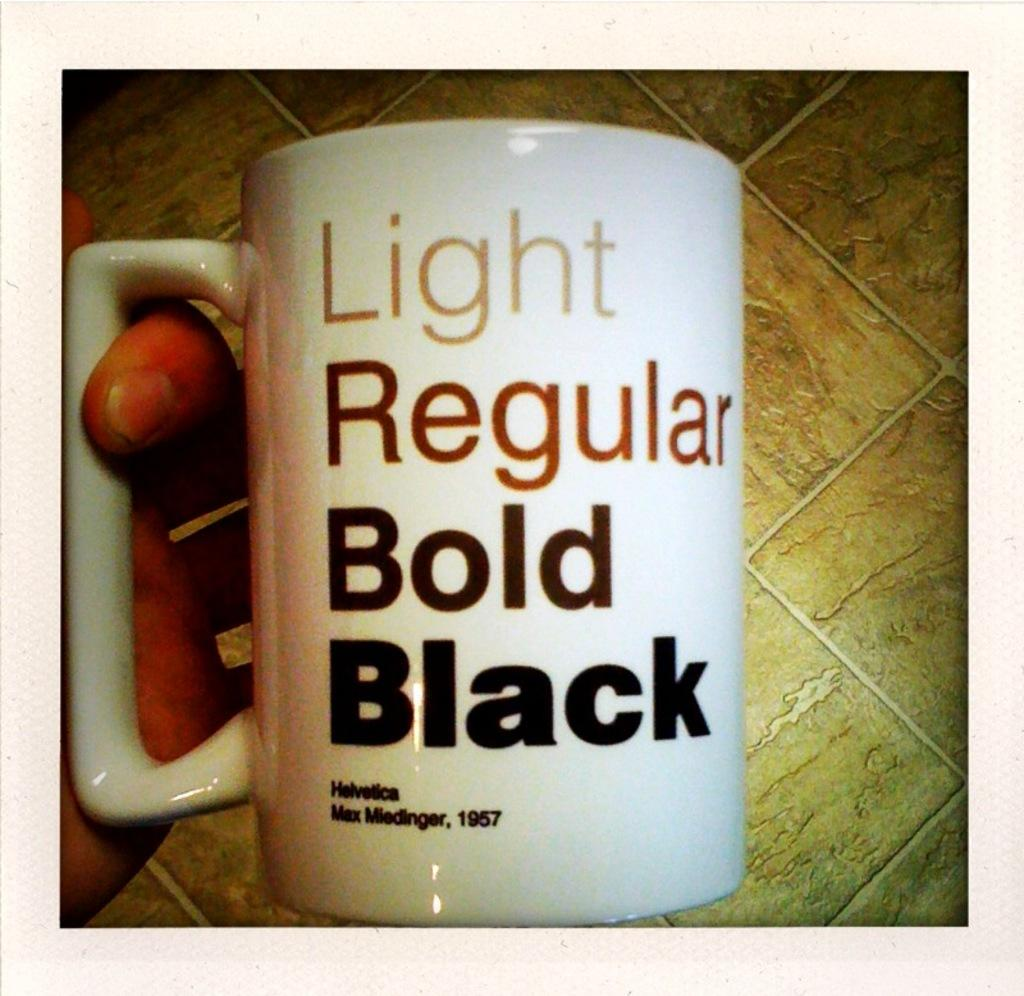<image>
Summarize the visual content of the image. White cup with the words "Light Regular Bold Black" on it. 